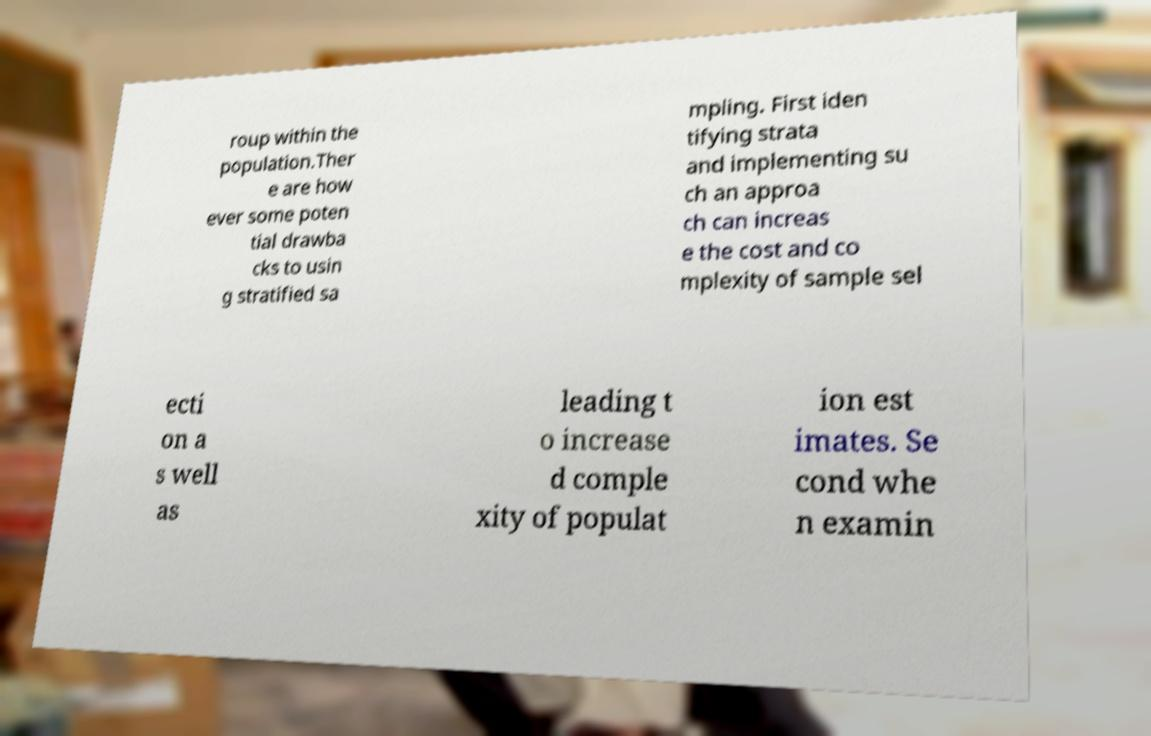Can you read and provide the text displayed in the image?This photo seems to have some interesting text. Can you extract and type it out for me? roup within the population.Ther e are how ever some poten tial drawba cks to usin g stratified sa mpling. First iden tifying strata and implementing su ch an approa ch can increas e the cost and co mplexity of sample sel ecti on a s well as leading t o increase d comple xity of populat ion est imates. Se cond whe n examin 